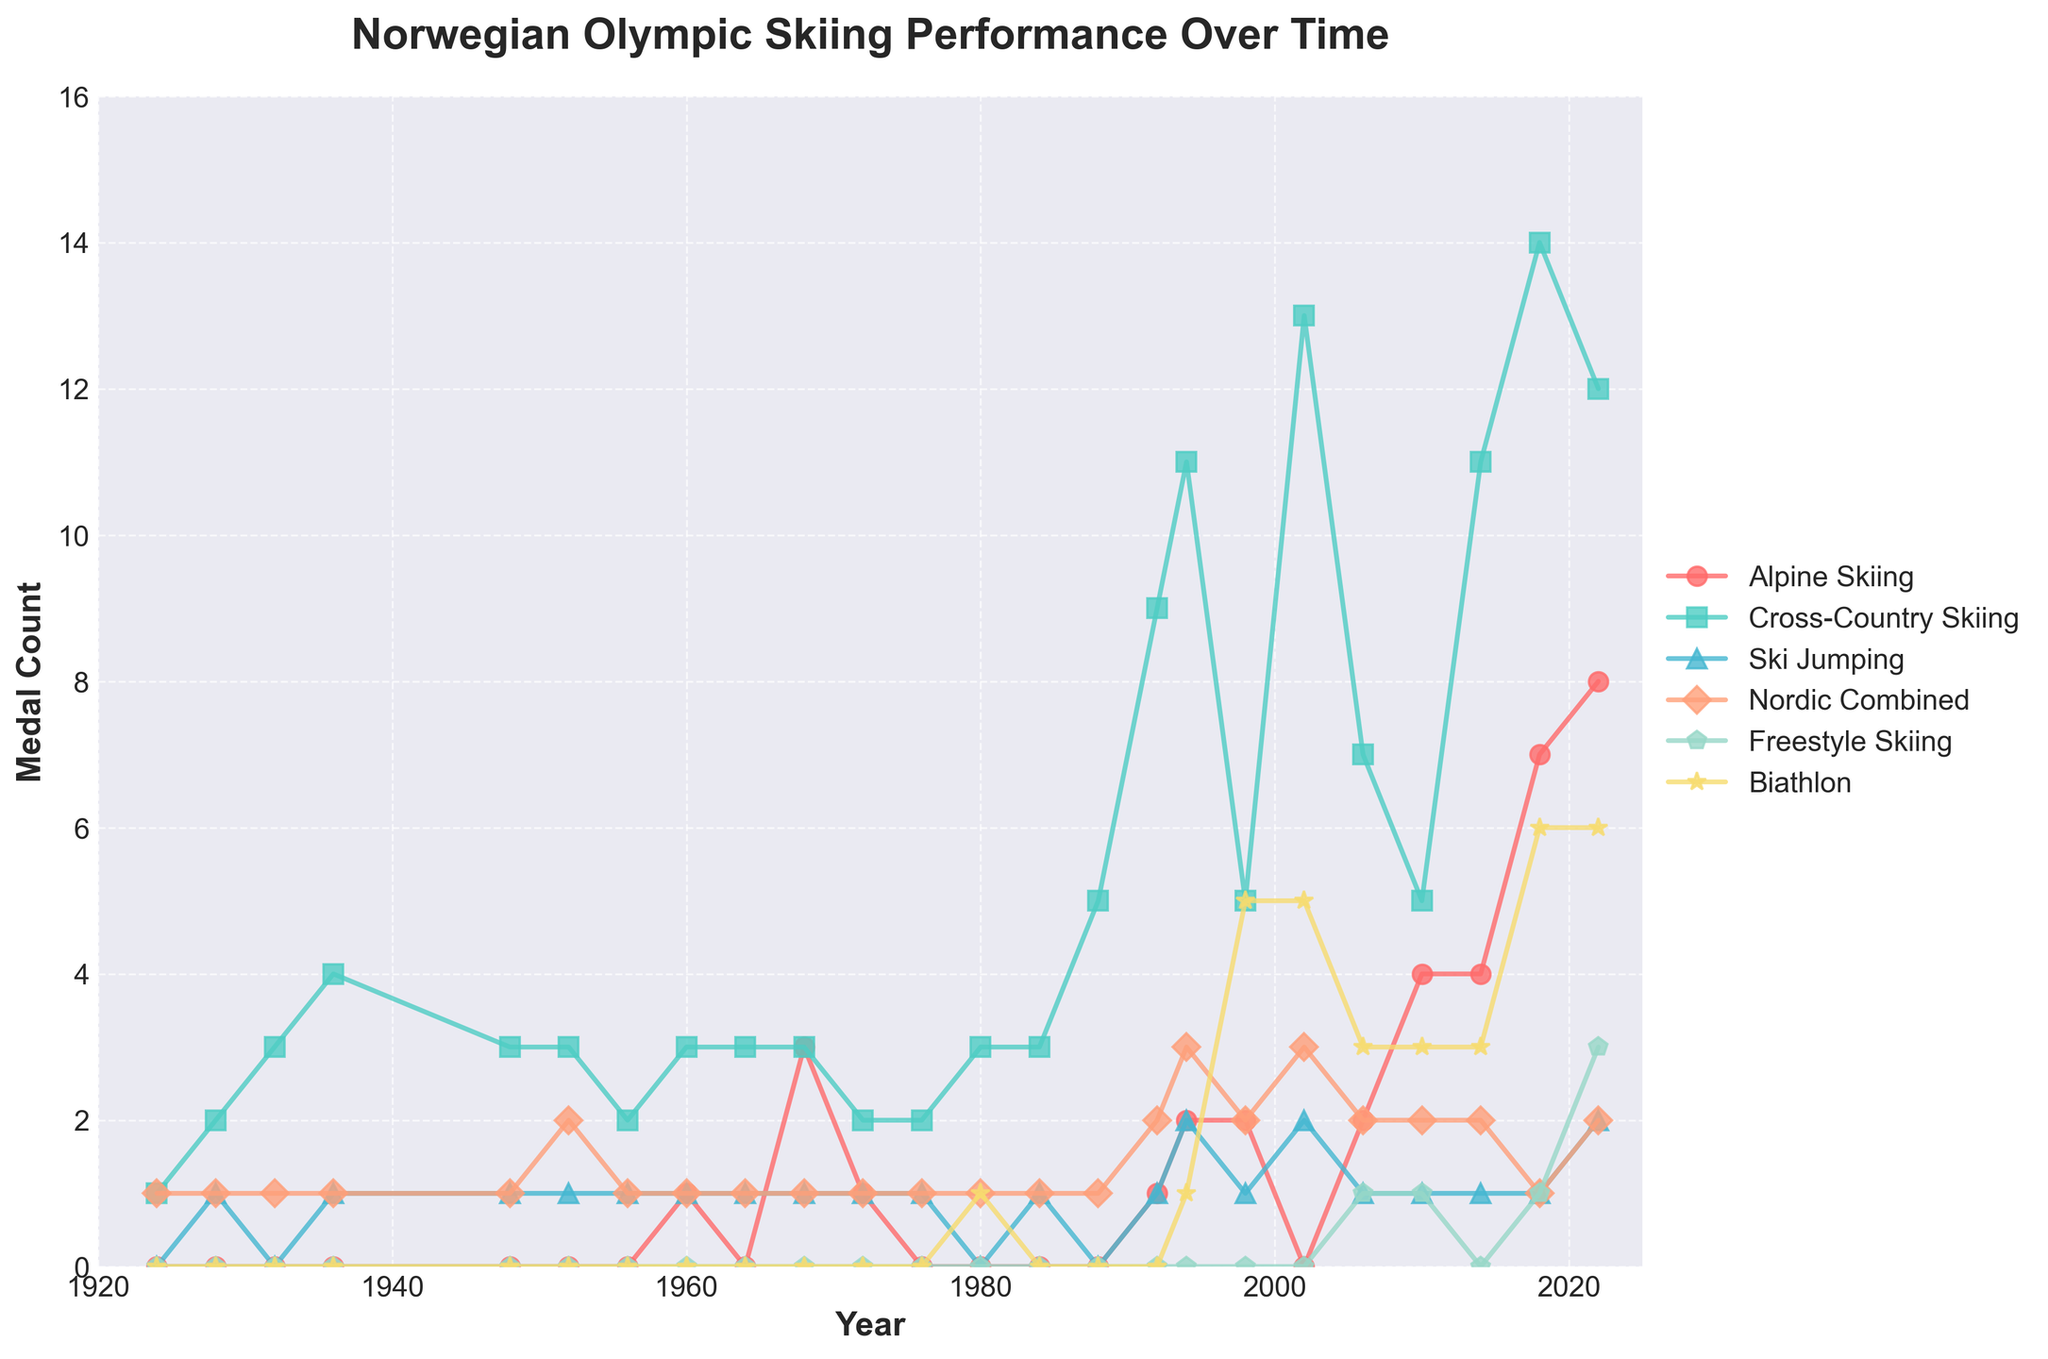What is the overall trend in cross-country skiing medal counts from 1924 to 2022? Cross-country skiing medal counts have generally increased over time. The trend shows a steady increase, with significant jumps around 1992, 1994, and 2002, reaching its peak in 2018.
Answer: Increasing Which discipline had the highest number of medals in the year 2018? In the year 2018, the discipline with the highest number of medals is Cross-Country Skiing, followed by Biathlon.
Answer: Cross-Country Skiing In which year did alpine skiing first have more than one medal? Alpine skiing first had more than one medal in the year 1968 when it won 3 medals.
Answer: 1968 How many total medals were won in cross-country skiing and biathlon in 2002? Cross-country skiing had 13 medals, and biathlon had 5 medals in 2002. Summing these gives 13 + 5 = 18 medals.
Answer: 18 Compare the number of medals won in freestyle skiing in 2022 to the number won in 2010. Freestyle skiing had 3 medals in 2022, while it had 1 medal in 2010. Hence, 2022 had more medals in freestyle skiing.
Answer: 2022 had more Which discipline shows a clear increasing trend starting from the 1980s? Biathlon shows a clear increasing trend starting from the 1980s, gradually increasing with a notable rise from 1998 onwards.
Answer: Biathlon Between 1994 and 2018, which year had the highest medals in Ski Jumping? In this period, 1994 and 2002 had the highest medals in Ski Jumping with 2 medals each.
Answer: 1994 and 2002 Did Nordic Combined ever have the same number of medals in back-to-back Olympics? Provide examples. Yes, Nordic Combined had the same number of medals (1 medal) in back-to-back Olympics from 1924 to 1948 and from 1984 to 2002.
Answer: Yes, 1924-1948 and 1984-2002 What is the difference in the number of medals won in alpine skiing between 1960 and 2022? Alpine skiing had 1 medal in 1960 and 8 medals in 2022. The difference is 8 - 1 = 7 medals.
Answer: 7 Identify the year when cross-country skiing medals hit double digits for the first time. Cross-country skiing first hit double digits in medal counts in the year 1994 when it won 11 medals.
Answer: 1994 